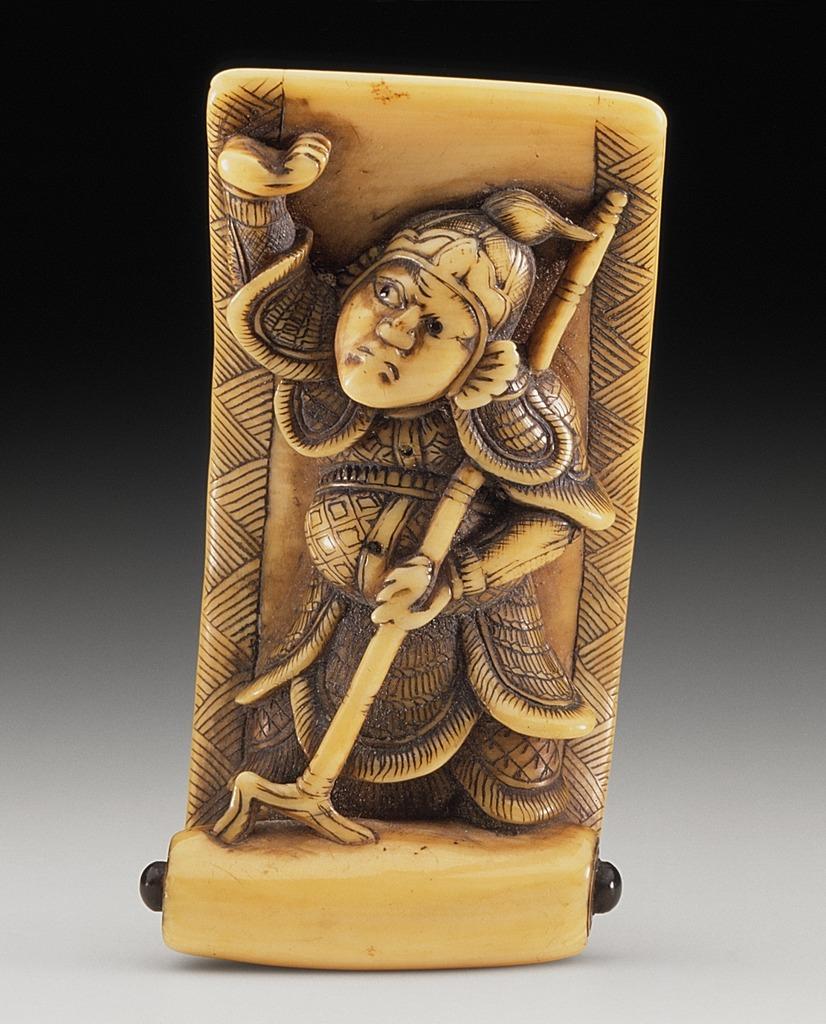Describe this image in one or two sentences. In this image there is a sculpture of a person. 